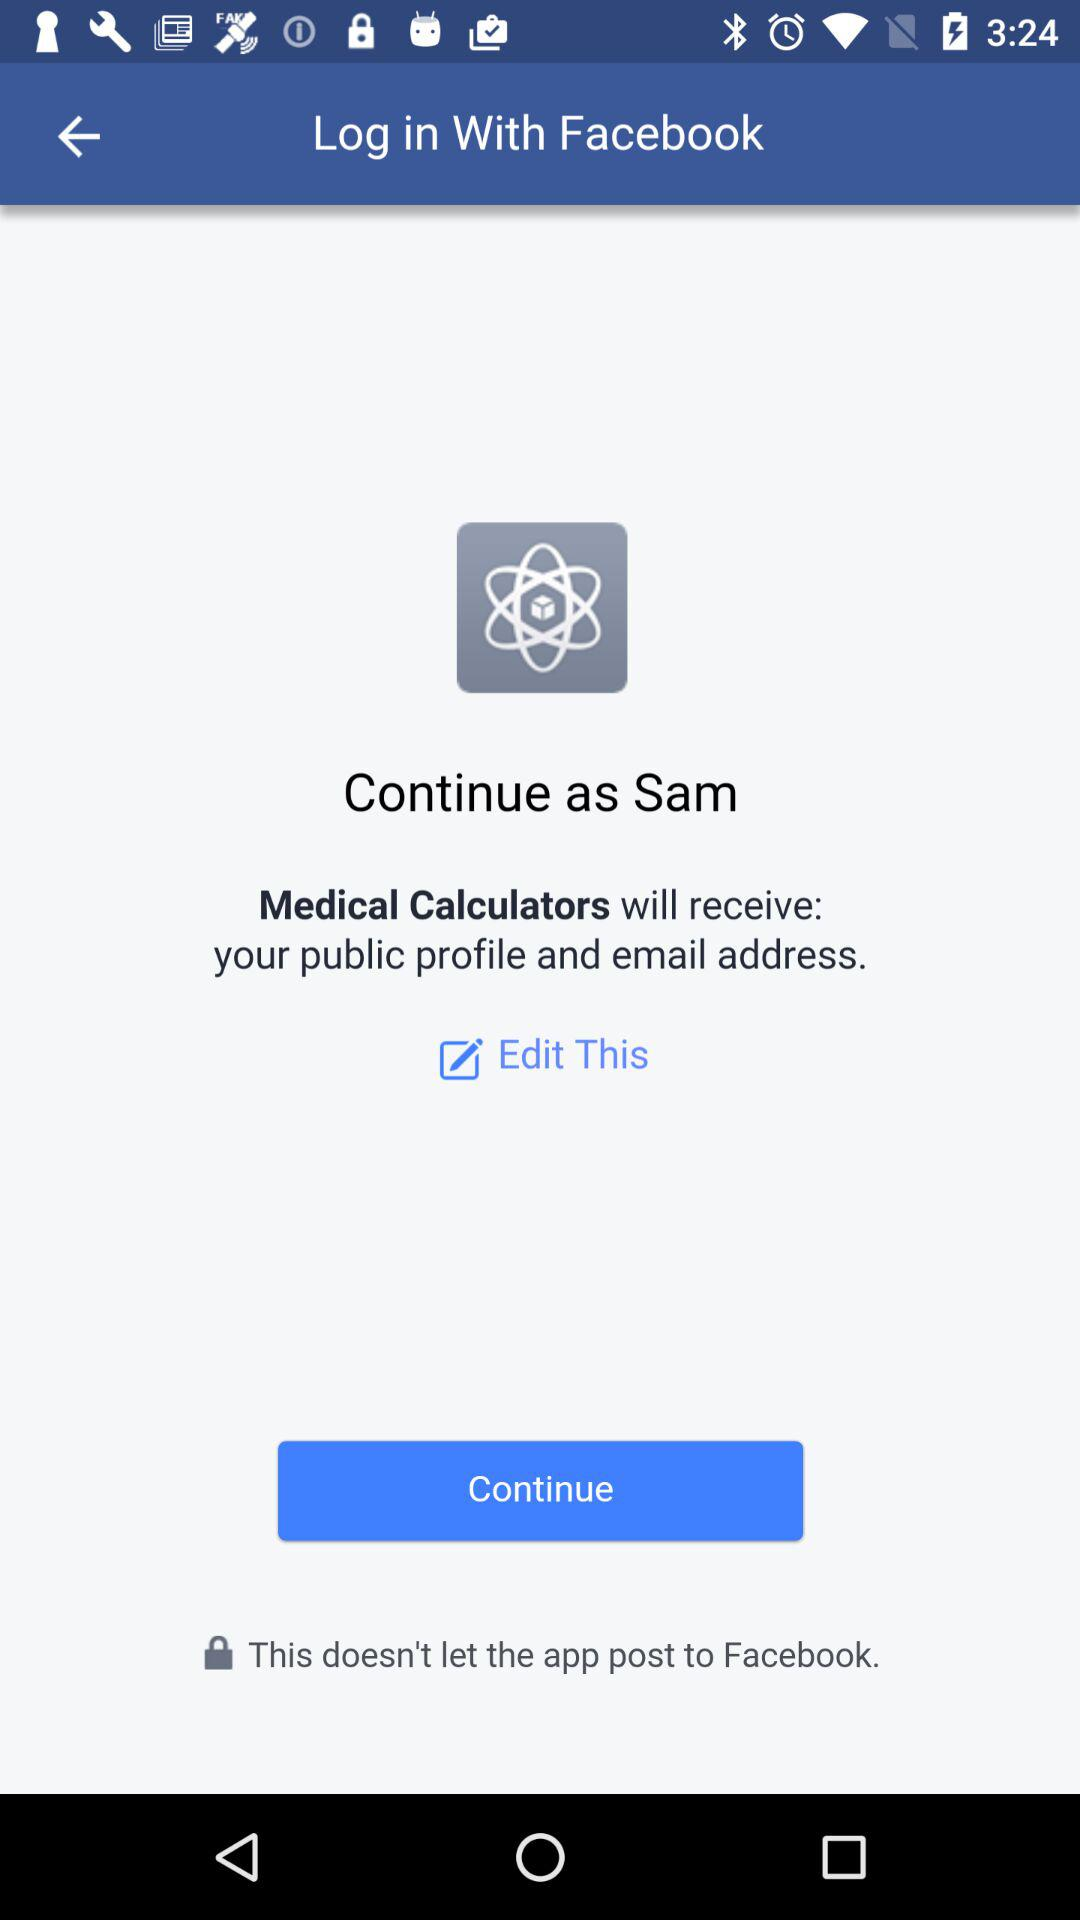Which email address will "Medical Calculators" have access to?
When the provided information is insufficient, respond with <no answer>. <no answer> 